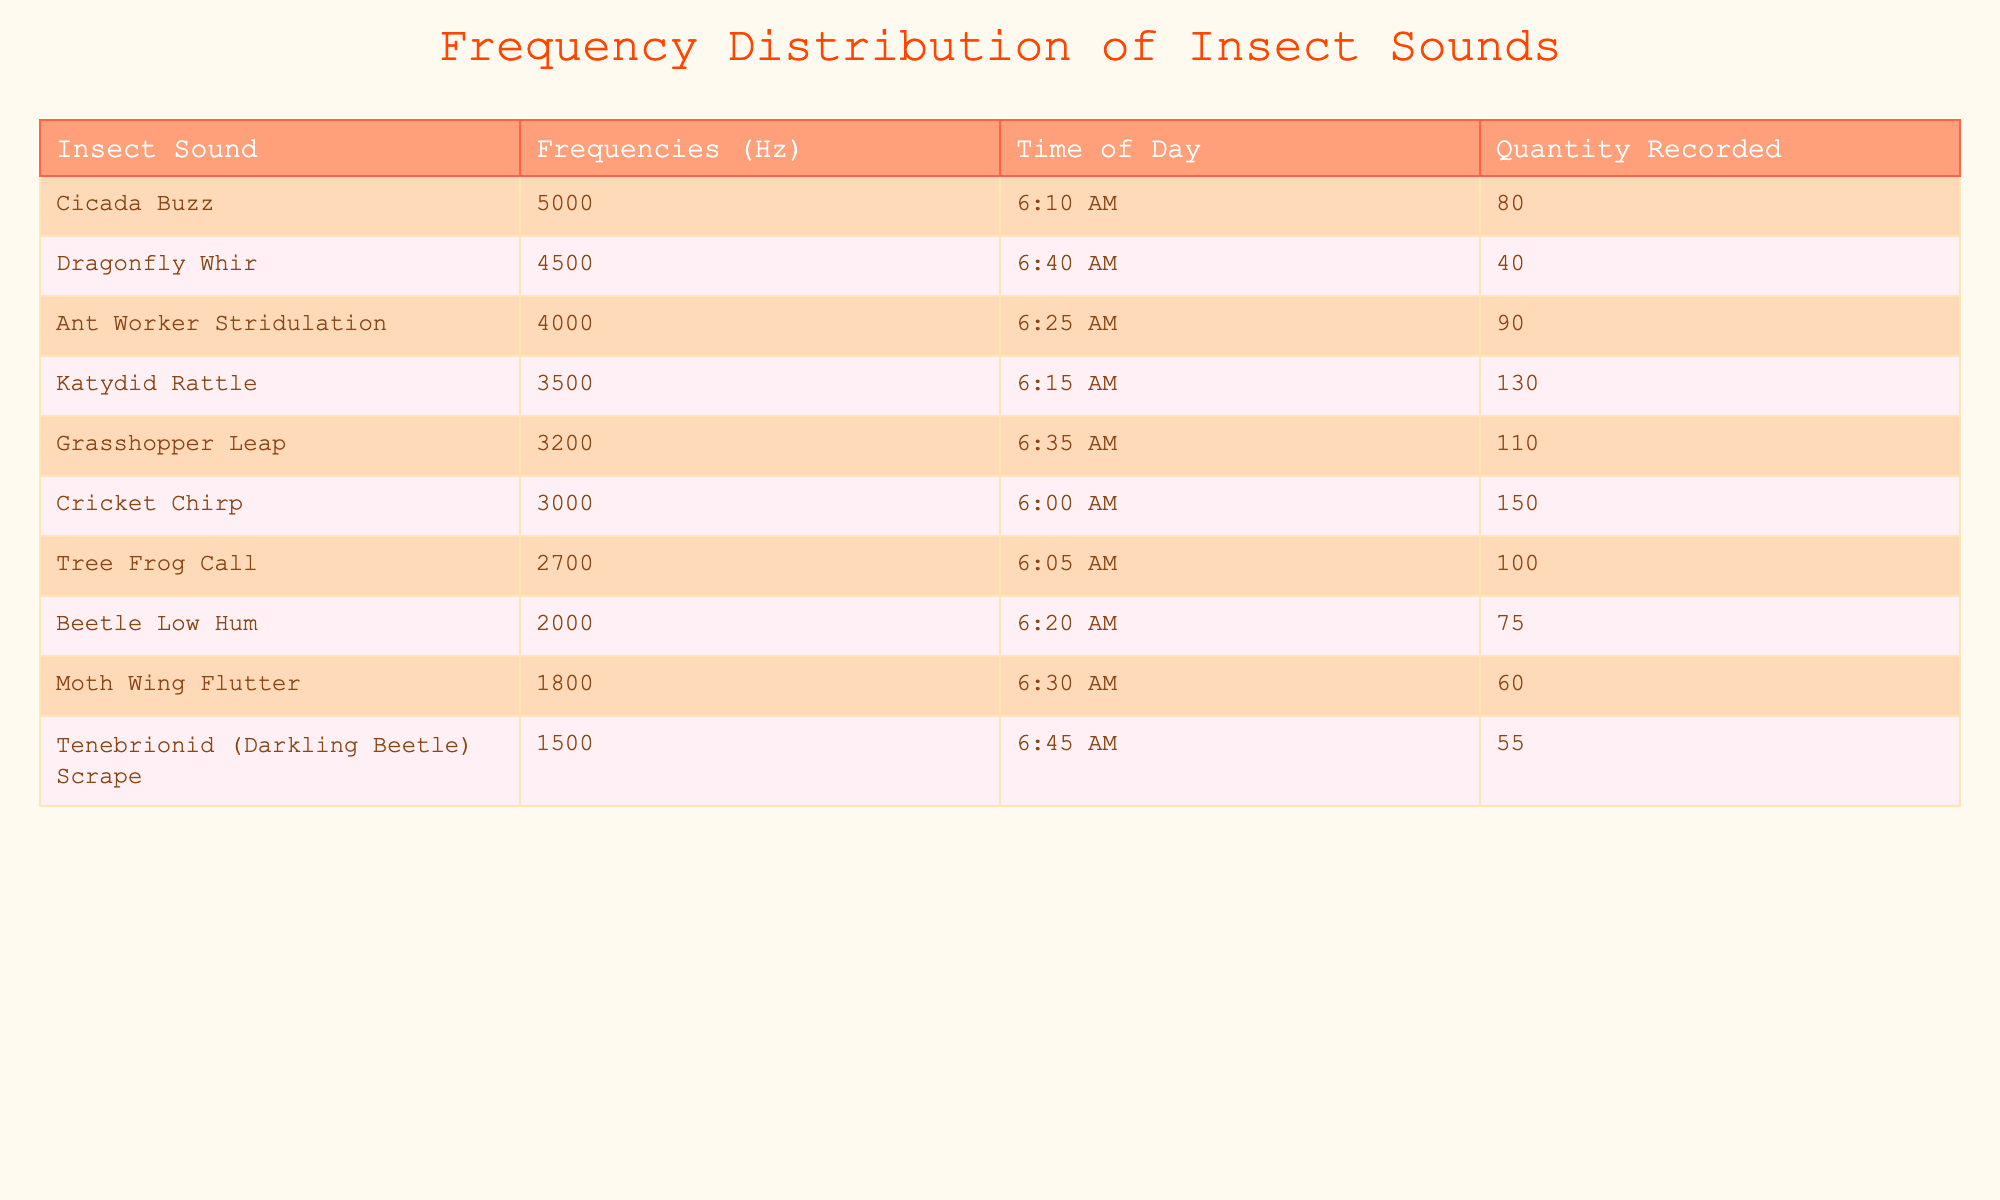What is the frequency of Cricket Chirp? The table lists "Cricket Chirp" under the "Insect Sound" column, and its corresponding frequency in the "Frequencies (Hz)" column is 3000 Hz.
Answer: 3000 Hz Which insect sound has the highest frequency? By examining the "Frequencies (Hz)" column, the highest value recorded is 5000 Hz associated with "Cicada Buzz."
Answer: Cicada Buzz How many Ant Worker Stridulations were recorded? The "Quantity Recorded" column indicates that under "Ant Worker Stridulation," the number recorded is 90.
Answer: 90 What is the average frequency of the recorded insect sounds? To find the average frequency, sum all the recorded frequencies (3000 + 2700 + 5000 + 3500 + 2000 + 4000 + 1800 + 3200 + 4500 + 1500 = 28500). Then divide by the number of sounds (10), which gives 28500 / 10 = 2850 Hz.
Answer: 2850 Hz Did the Moth Wing Flutter produce a sound frequency higher than 2000 Hz? In the "Frequencies (Hz)" column, Moth Wing Flutter has a frequency of 1800 Hz, which is lower than 2000 Hz. Therefore, the statement is false.
Answer: No How many sounds were recorded at frequencies below 3000 Hz? By examining the "Frequencies (Hz)" column, the sounds below 3000 Hz are "Beetle Low Hum" (2000 Hz), "Moth Wing Flutter" (1800 Hz), and "Tenebrionid (Darkling Beetle) Scrape" (1500 Hz), totaling three sounds.
Answer: 3 Which insect sound has a recording quantity of more than 100? Checking the "Quantity Recorded" column, "Cricket Chirp" (150), "Katydid Rattle" (130), and "Grasshopper Leap" (110) have quantities above 100.
Answer: Cricket Chirp, Katydid Rattle, Grasshopper Leap What is the combined quantity of sounds recorded for frequencies over 4000 Hz? The sounds over 4000 Hz are "Cicada Buzz" (80), "Ant Worker Stridulation" (90), and "Dragonfly Whir" (40). Adding these quantities, we get 80 + 90 + 40 = 210.
Answer: 210 Is there any insect sound recorded at exactly 1500 Hz? The table shows that "Tenebrionid (Darkling Beetle) Scrape" is the only sound recorded at 1500 Hz, confirming that there is indeed a sound at this frequency.
Answer: Yes 